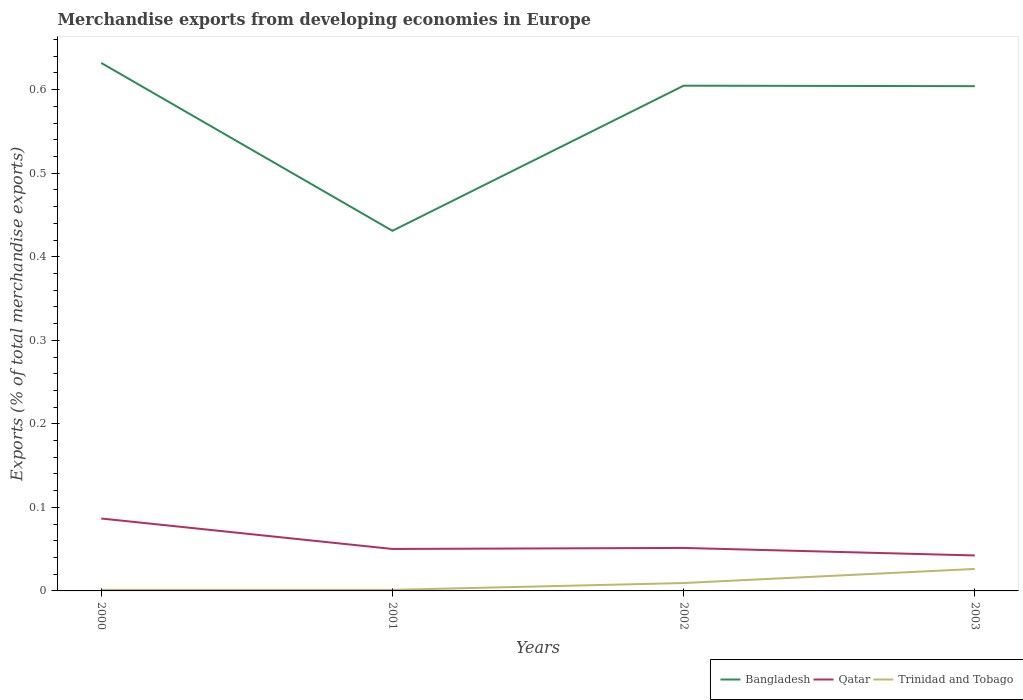How many different coloured lines are there?
Make the answer very short. 3. Is the number of lines equal to the number of legend labels?
Keep it short and to the point. Yes. Across all years, what is the maximum percentage of total merchandise exports in Bangladesh?
Ensure brevity in your answer.  0.43. What is the total percentage of total merchandise exports in Bangladesh in the graph?
Keep it short and to the point. -0.17. What is the difference between the highest and the second highest percentage of total merchandise exports in Trinidad and Tobago?
Make the answer very short. 0.03. Is the percentage of total merchandise exports in Bangladesh strictly greater than the percentage of total merchandise exports in Qatar over the years?
Your response must be concise. No. How many lines are there?
Your answer should be very brief. 3. How many years are there in the graph?
Give a very brief answer. 4. Are the values on the major ticks of Y-axis written in scientific E-notation?
Offer a very short reply. No. Does the graph contain any zero values?
Offer a terse response. No. Does the graph contain grids?
Ensure brevity in your answer.  No. Where does the legend appear in the graph?
Your response must be concise. Bottom right. What is the title of the graph?
Your answer should be very brief. Merchandise exports from developing economies in Europe. Does "Botswana" appear as one of the legend labels in the graph?
Make the answer very short. No. What is the label or title of the Y-axis?
Keep it short and to the point. Exports (% of total merchandise exports). What is the Exports (% of total merchandise exports) in Bangladesh in 2000?
Provide a short and direct response. 0.63. What is the Exports (% of total merchandise exports) of Qatar in 2000?
Keep it short and to the point. 0.09. What is the Exports (% of total merchandise exports) in Trinidad and Tobago in 2000?
Ensure brevity in your answer.  0. What is the Exports (% of total merchandise exports) of Bangladesh in 2001?
Keep it short and to the point. 0.43. What is the Exports (% of total merchandise exports) in Qatar in 2001?
Your answer should be compact. 0.05. What is the Exports (% of total merchandise exports) in Trinidad and Tobago in 2001?
Provide a short and direct response. 0. What is the Exports (% of total merchandise exports) in Bangladesh in 2002?
Provide a succinct answer. 0.6. What is the Exports (% of total merchandise exports) in Qatar in 2002?
Provide a succinct answer. 0.05. What is the Exports (% of total merchandise exports) in Trinidad and Tobago in 2002?
Your response must be concise. 0.01. What is the Exports (% of total merchandise exports) in Bangladesh in 2003?
Offer a terse response. 0.6. What is the Exports (% of total merchandise exports) of Qatar in 2003?
Offer a terse response. 0.04. What is the Exports (% of total merchandise exports) of Trinidad and Tobago in 2003?
Provide a short and direct response. 0.03. Across all years, what is the maximum Exports (% of total merchandise exports) of Bangladesh?
Provide a succinct answer. 0.63. Across all years, what is the maximum Exports (% of total merchandise exports) in Qatar?
Offer a terse response. 0.09. Across all years, what is the maximum Exports (% of total merchandise exports) of Trinidad and Tobago?
Provide a succinct answer. 0.03. Across all years, what is the minimum Exports (% of total merchandise exports) of Bangladesh?
Your answer should be very brief. 0.43. Across all years, what is the minimum Exports (% of total merchandise exports) in Qatar?
Keep it short and to the point. 0.04. Across all years, what is the minimum Exports (% of total merchandise exports) of Trinidad and Tobago?
Offer a very short reply. 0. What is the total Exports (% of total merchandise exports) of Bangladesh in the graph?
Provide a short and direct response. 2.27. What is the total Exports (% of total merchandise exports) in Qatar in the graph?
Offer a very short reply. 0.23. What is the total Exports (% of total merchandise exports) of Trinidad and Tobago in the graph?
Offer a very short reply. 0.04. What is the difference between the Exports (% of total merchandise exports) of Bangladesh in 2000 and that in 2001?
Your answer should be compact. 0.2. What is the difference between the Exports (% of total merchandise exports) in Qatar in 2000 and that in 2001?
Your answer should be compact. 0.04. What is the difference between the Exports (% of total merchandise exports) of Trinidad and Tobago in 2000 and that in 2001?
Offer a very short reply. 0. What is the difference between the Exports (% of total merchandise exports) of Bangladesh in 2000 and that in 2002?
Your answer should be very brief. 0.03. What is the difference between the Exports (% of total merchandise exports) in Qatar in 2000 and that in 2002?
Make the answer very short. 0.04. What is the difference between the Exports (% of total merchandise exports) in Trinidad and Tobago in 2000 and that in 2002?
Make the answer very short. -0.01. What is the difference between the Exports (% of total merchandise exports) in Bangladesh in 2000 and that in 2003?
Your answer should be compact. 0.03. What is the difference between the Exports (% of total merchandise exports) in Qatar in 2000 and that in 2003?
Provide a succinct answer. 0.04. What is the difference between the Exports (% of total merchandise exports) of Trinidad and Tobago in 2000 and that in 2003?
Make the answer very short. -0.03. What is the difference between the Exports (% of total merchandise exports) of Bangladesh in 2001 and that in 2002?
Give a very brief answer. -0.17. What is the difference between the Exports (% of total merchandise exports) of Qatar in 2001 and that in 2002?
Offer a terse response. -0. What is the difference between the Exports (% of total merchandise exports) in Trinidad and Tobago in 2001 and that in 2002?
Your answer should be very brief. -0.01. What is the difference between the Exports (% of total merchandise exports) of Bangladesh in 2001 and that in 2003?
Give a very brief answer. -0.17. What is the difference between the Exports (% of total merchandise exports) in Qatar in 2001 and that in 2003?
Keep it short and to the point. 0.01. What is the difference between the Exports (% of total merchandise exports) of Trinidad and Tobago in 2001 and that in 2003?
Make the answer very short. -0.03. What is the difference between the Exports (% of total merchandise exports) in Bangladesh in 2002 and that in 2003?
Your answer should be very brief. 0. What is the difference between the Exports (% of total merchandise exports) of Qatar in 2002 and that in 2003?
Offer a very short reply. 0.01. What is the difference between the Exports (% of total merchandise exports) in Trinidad and Tobago in 2002 and that in 2003?
Your answer should be very brief. -0.02. What is the difference between the Exports (% of total merchandise exports) in Bangladesh in 2000 and the Exports (% of total merchandise exports) in Qatar in 2001?
Offer a very short reply. 0.58. What is the difference between the Exports (% of total merchandise exports) of Bangladesh in 2000 and the Exports (% of total merchandise exports) of Trinidad and Tobago in 2001?
Provide a short and direct response. 0.63. What is the difference between the Exports (% of total merchandise exports) in Qatar in 2000 and the Exports (% of total merchandise exports) in Trinidad and Tobago in 2001?
Keep it short and to the point. 0.09. What is the difference between the Exports (% of total merchandise exports) of Bangladesh in 2000 and the Exports (% of total merchandise exports) of Qatar in 2002?
Offer a very short reply. 0.58. What is the difference between the Exports (% of total merchandise exports) in Bangladesh in 2000 and the Exports (% of total merchandise exports) in Trinidad and Tobago in 2002?
Your response must be concise. 0.62. What is the difference between the Exports (% of total merchandise exports) in Qatar in 2000 and the Exports (% of total merchandise exports) in Trinidad and Tobago in 2002?
Offer a very short reply. 0.08. What is the difference between the Exports (% of total merchandise exports) of Bangladesh in 2000 and the Exports (% of total merchandise exports) of Qatar in 2003?
Offer a terse response. 0.59. What is the difference between the Exports (% of total merchandise exports) of Bangladesh in 2000 and the Exports (% of total merchandise exports) of Trinidad and Tobago in 2003?
Your answer should be very brief. 0.61. What is the difference between the Exports (% of total merchandise exports) in Qatar in 2000 and the Exports (% of total merchandise exports) in Trinidad and Tobago in 2003?
Your answer should be very brief. 0.06. What is the difference between the Exports (% of total merchandise exports) of Bangladesh in 2001 and the Exports (% of total merchandise exports) of Qatar in 2002?
Make the answer very short. 0.38. What is the difference between the Exports (% of total merchandise exports) of Bangladesh in 2001 and the Exports (% of total merchandise exports) of Trinidad and Tobago in 2002?
Ensure brevity in your answer.  0.42. What is the difference between the Exports (% of total merchandise exports) in Qatar in 2001 and the Exports (% of total merchandise exports) in Trinidad and Tobago in 2002?
Keep it short and to the point. 0.04. What is the difference between the Exports (% of total merchandise exports) in Bangladesh in 2001 and the Exports (% of total merchandise exports) in Qatar in 2003?
Give a very brief answer. 0.39. What is the difference between the Exports (% of total merchandise exports) in Bangladesh in 2001 and the Exports (% of total merchandise exports) in Trinidad and Tobago in 2003?
Your response must be concise. 0.4. What is the difference between the Exports (% of total merchandise exports) of Qatar in 2001 and the Exports (% of total merchandise exports) of Trinidad and Tobago in 2003?
Provide a short and direct response. 0.02. What is the difference between the Exports (% of total merchandise exports) in Bangladesh in 2002 and the Exports (% of total merchandise exports) in Qatar in 2003?
Offer a terse response. 0.56. What is the difference between the Exports (% of total merchandise exports) in Bangladesh in 2002 and the Exports (% of total merchandise exports) in Trinidad and Tobago in 2003?
Give a very brief answer. 0.58. What is the difference between the Exports (% of total merchandise exports) in Qatar in 2002 and the Exports (% of total merchandise exports) in Trinidad and Tobago in 2003?
Give a very brief answer. 0.03. What is the average Exports (% of total merchandise exports) of Bangladesh per year?
Your answer should be compact. 0.57. What is the average Exports (% of total merchandise exports) of Qatar per year?
Make the answer very short. 0.06. What is the average Exports (% of total merchandise exports) of Trinidad and Tobago per year?
Offer a very short reply. 0.01. In the year 2000, what is the difference between the Exports (% of total merchandise exports) in Bangladesh and Exports (% of total merchandise exports) in Qatar?
Keep it short and to the point. 0.55. In the year 2000, what is the difference between the Exports (% of total merchandise exports) in Bangladesh and Exports (% of total merchandise exports) in Trinidad and Tobago?
Give a very brief answer. 0.63. In the year 2000, what is the difference between the Exports (% of total merchandise exports) in Qatar and Exports (% of total merchandise exports) in Trinidad and Tobago?
Your answer should be compact. 0.09. In the year 2001, what is the difference between the Exports (% of total merchandise exports) in Bangladesh and Exports (% of total merchandise exports) in Qatar?
Your response must be concise. 0.38. In the year 2001, what is the difference between the Exports (% of total merchandise exports) in Bangladesh and Exports (% of total merchandise exports) in Trinidad and Tobago?
Your answer should be very brief. 0.43. In the year 2001, what is the difference between the Exports (% of total merchandise exports) in Qatar and Exports (% of total merchandise exports) in Trinidad and Tobago?
Keep it short and to the point. 0.05. In the year 2002, what is the difference between the Exports (% of total merchandise exports) of Bangladesh and Exports (% of total merchandise exports) of Qatar?
Provide a short and direct response. 0.55. In the year 2002, what is the difference between the Exports (% of total merchandise exports) in Bangladesh and Exports (% of total merchandise exports) in Trinidad and Tobago?
Give a very brief answer. 0.6. In the year 2002, what is the difference between the Exports (% of total merchandise exports) of Qatar and Exports (% of total merchandise exports) of Trinidad and Tobago?
Offer a very short reply. 0.04. In the year 2003, what is the difference between the Exports (% of total merchandise exports) of Bangladesh and Exports (% of total merchandise exports) of Qatar?
Offer a terse response. 0.56. In the year 2003, what is the difference between the Exports (% of total merchandise exports) of Bangladesh and Exports (% of total merchandise exports) of Trinidad and Tobago?
Your answer should be very brief. 0.58. In the year 2003, what is the difference between the Exports (% of total merchandise exports) in Qatar and Exports (% of total merchandise exports) in Trinidad and Tobago?
Provide a succinct answer. 0.02. What is the ratio of the Exports (% of total merchandise exports) in Bangladesh in 2000 to that in 2001?
Your answer should be compact. 1.47. What is the ratio of the Exports (% of total merchandise exports) of Qatar in 2000 to that in 2001?
Make the answer very short. 1.73. What is the ratio of the Exports (% of total merchandise exports) in Trinidad and Tobago in 2000 to that in 2001?
Ensure brevity in your answer.  1.01. What is the ratio of the Exports (% of total merchandise exports) in Bangladesh in 2000 to that in 2002?
Make the answer very short. 1.05. What is the ratio of the Exports (% of total merchandise exports) in Qatar in 2000 to that in 2002?
Make the answer very short. 1.68. What is the ratio of the Exports (% of total merchandise exports) of Trinidad and Tobago in 2000 to that in 2002?
Ensure brevity in your answer.  0.13. What is the ratio of the Exports (% of total merchandise exports) in Bangladesh in 2000 to that in 2003?
Ensure brevity in your answer.  1.05. What is the ratio of the Exports (% of total merchandise exports) of Qatar in 2000 to that in 2003?
Offer a very short reply. 2.04. What is the ratio of the Exports (% of total merchandise exports) of Trinidad and Tobago in 2000 to that in 2003?
Your response must be concise. 0.05. What is the ratio of the Exports (% of total merchandise exports) in Bangladesh in 2001 to that in 2002?
Make the answer very short. 0.71. What is the ratio of the Exports (% of total merchandise exports) in Qatar in 2001 to that in 2002?
Offer a terse response. 0.98. What is the ratio of the Exports (% of total merchandise exports) of Trinidad and Tobago in 2001 to that in 2002?
Your answer should be very brief. 0.13. What is the ratio of the Exports (% of total merchandise exports) of Bangladesh in 2001 to that in 2003?
Provide a short and direct response. 0.71. What is the ratio of the Exports (% of total merchandise exports) in Qatar in 2001 to that in 2003?
Your answer should be compact. 1.18. What is the ratio of the Exports (% of total merchandise exports) of Trinidad and Tobago in 2001 to that in 2003?
Ensure brevity in your answer.  0.05. What is the ratio of the Exports (% of total merchandise exports) of Qatar in 2002 to that in 2003?
Provide a short and direct response. 1.21. What is the ratio of the Exports (% of total merchandise exports) of Trinidad and Tobago in 2002 to that in 2003?
Ensure brevity in your answer.  0.36. What is the difference between the highest and the second highest Exports (% of total merchandise exports) of Bangladesh?
Provide a short and direct response. 0.03. What is the difference between the highest and the second highest Exports (% of total merchandise exports) in Qatar?
Ensure brevity in your answer.  0.04. What is the difference between the highest and the second highest Exports (% of total merchandise exports) in Trinidad and Tobago?
Your response must be concise. 0.02. What is the difference between the highest and the lowest Exports (% of total merchandise exports) of Bangladesh?
Offer a very short reply. 0.2. What is the difference between the highest and the lowest Exports (% of total merchandise exports) of Qatar?
Your response must be concise. 0.04. What is the difference between the highest and the lowest Exports (% of total merchandise exports) of Trinidad and Tobago?
Ensure brevity in your answer.  0.03. 